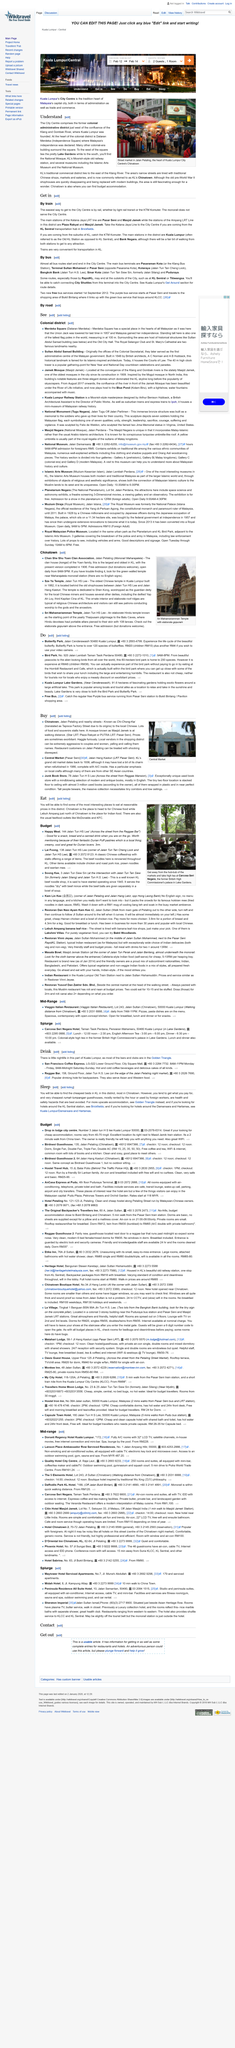Draw attention to some important aspects in this diagram. It has been observed that local vendors in the shopping district oftentimes exhibit aggressive behavior towards couples and women, which is unacceptable and must be addressed. Yes, the clan house of the Yuen family and the Sze Ya Temple are both located in Kuala Lumpur's Chinatown. The most effective method of reaching City Centre is by train, which can be taken via light rail transit or KTM Komuter. The street market in the photograph is located in Kuala Lumpur, and it can be inferred that the photograph was taken in this city. The Kelana Jaya LRT line has two main stations: Pasar Seni and Masjid Jamek. 